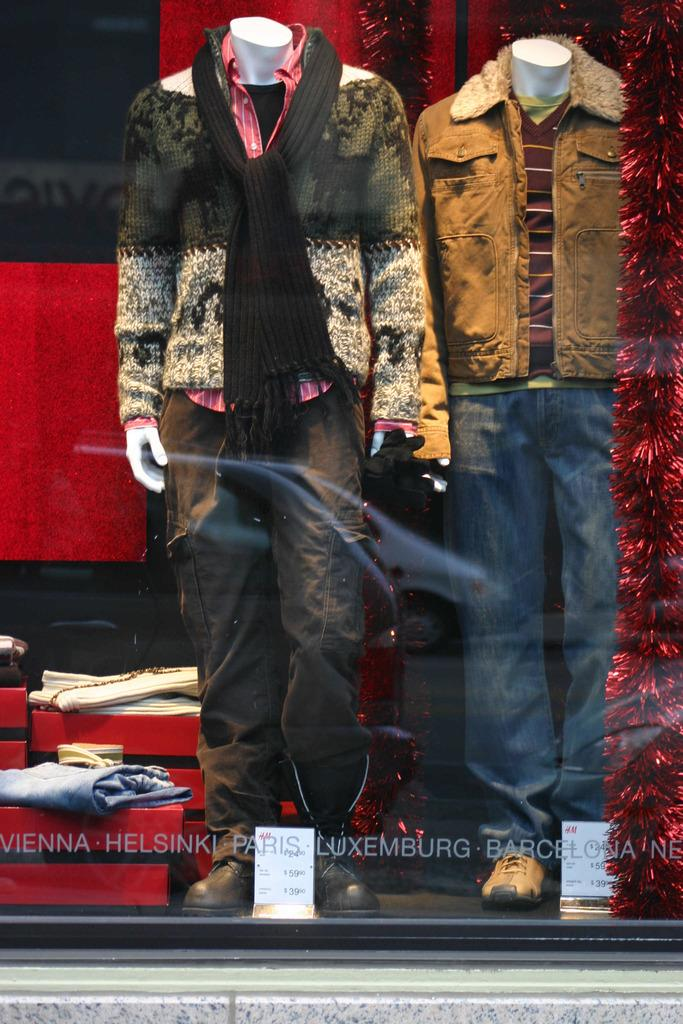What type of window is shown in the image? There is a glass window in the image. What can be seen through the glass window? Mannequins are visible through the glass window. What are the mannequins wearing? Clothes are present on the mannequins. Can you see any cows grazing in the field behind the mannequins? There is no field or cows present in the image; it only shows a glass window with mannequins wearing clothes. 